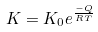<formula> <loc_0><loc_0><loc_500><loc_500>K = K _ { 0 } e ^ { \frac { - Q } { R T } }</formula> 